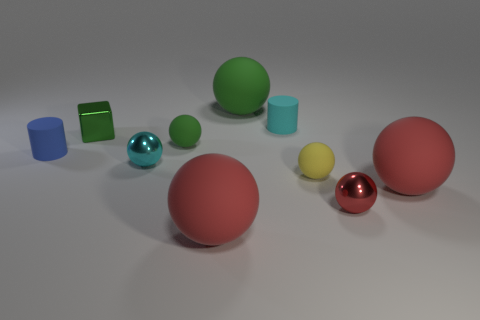Subtract all red spheres. How many were subtracted if there are1red spheres left? 2 Subtract all brown cubes. How many red spheres are left? 3 Subtract 2 spheres. How many spheres are left? 5 Subtract all big green balls. How many balls are left? 6 Subtract all green spheres. How many spheres are left? 5 Subtract all purple spheres. Subtract all brown cylinders. How many spheres are left? 7 Subtract all blocks. How many objects are left? 9 Add 3 small green metal things. How many small green metal things are left? 4 Add 4 cyan shiny things. How many cyan shiny things exist? 5 Subtract 3 red balls. How many objects are left? 7 